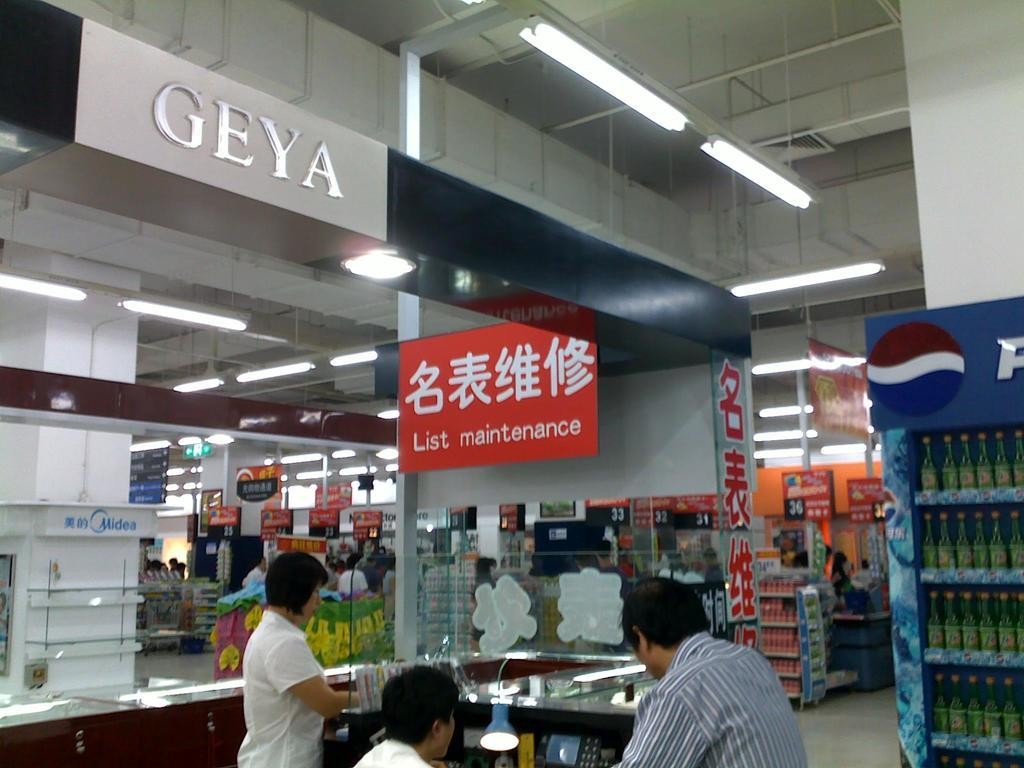<image>
Relay a brief, clear account of the picture shown. A group of people in a store called geya. 